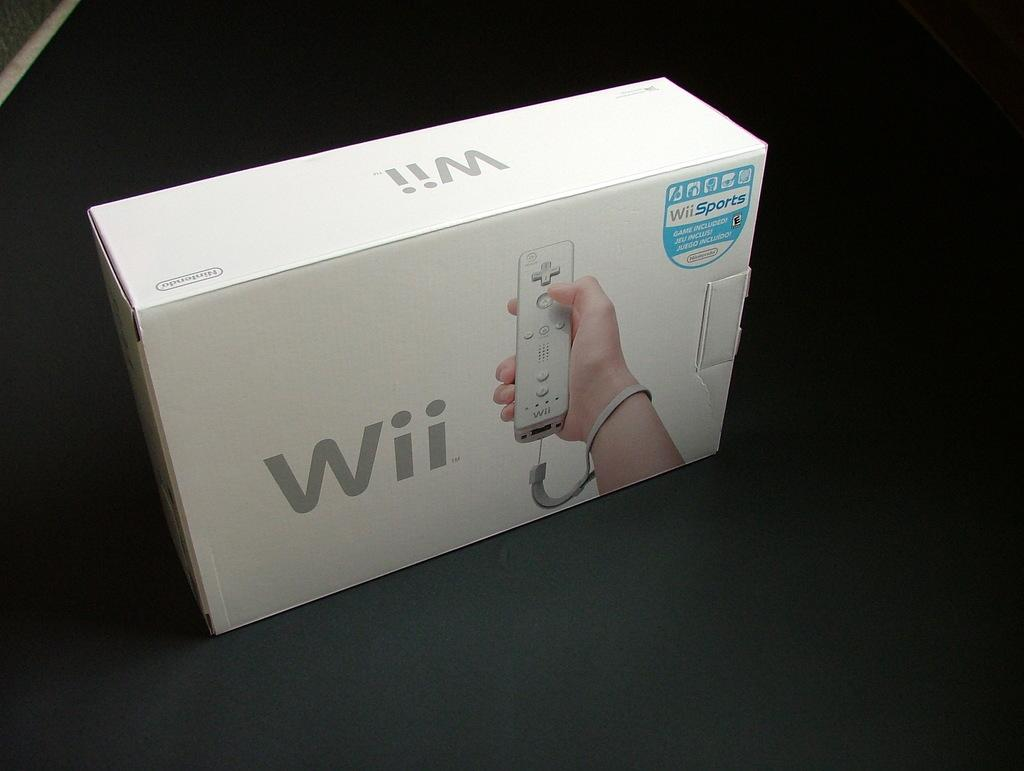<image>
Provide a brief description of the given image. A white box contains a Nintendo Wii, packaged with Wii Sports. 